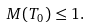Convert formula to latex. <formula><loc_0><loc_0><loc_500><loc_500>M ( T _ { 0 } ) \leq 1 .</formula> 